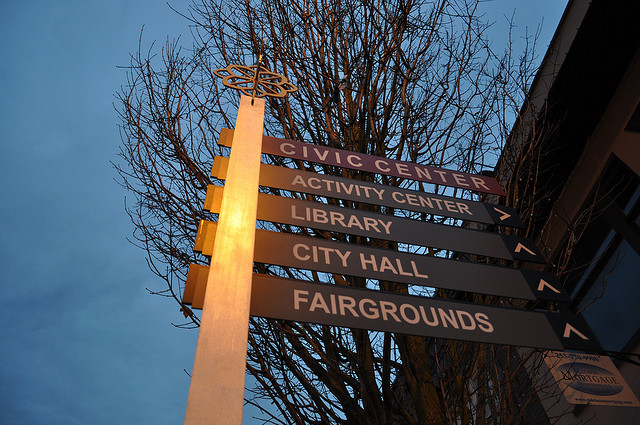Read all the text in this image. CIVIC CENTER ACTIVITY CENTER LIBRARY MORTGAGE FAIRGROUNDS HALL CITY 